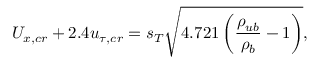Convert formula to latex. <formula><loc_0><loc_0><loc_500><loc_500>U _ { x , c r } + 2 . 4 u _ { \tau , c r } = s _ { T } \sqrt { 4 . 7 2 1 \left ( \frac { \rho _ { u b } } { \rho _ { b } } - 1 \right ) } ,</formula> 